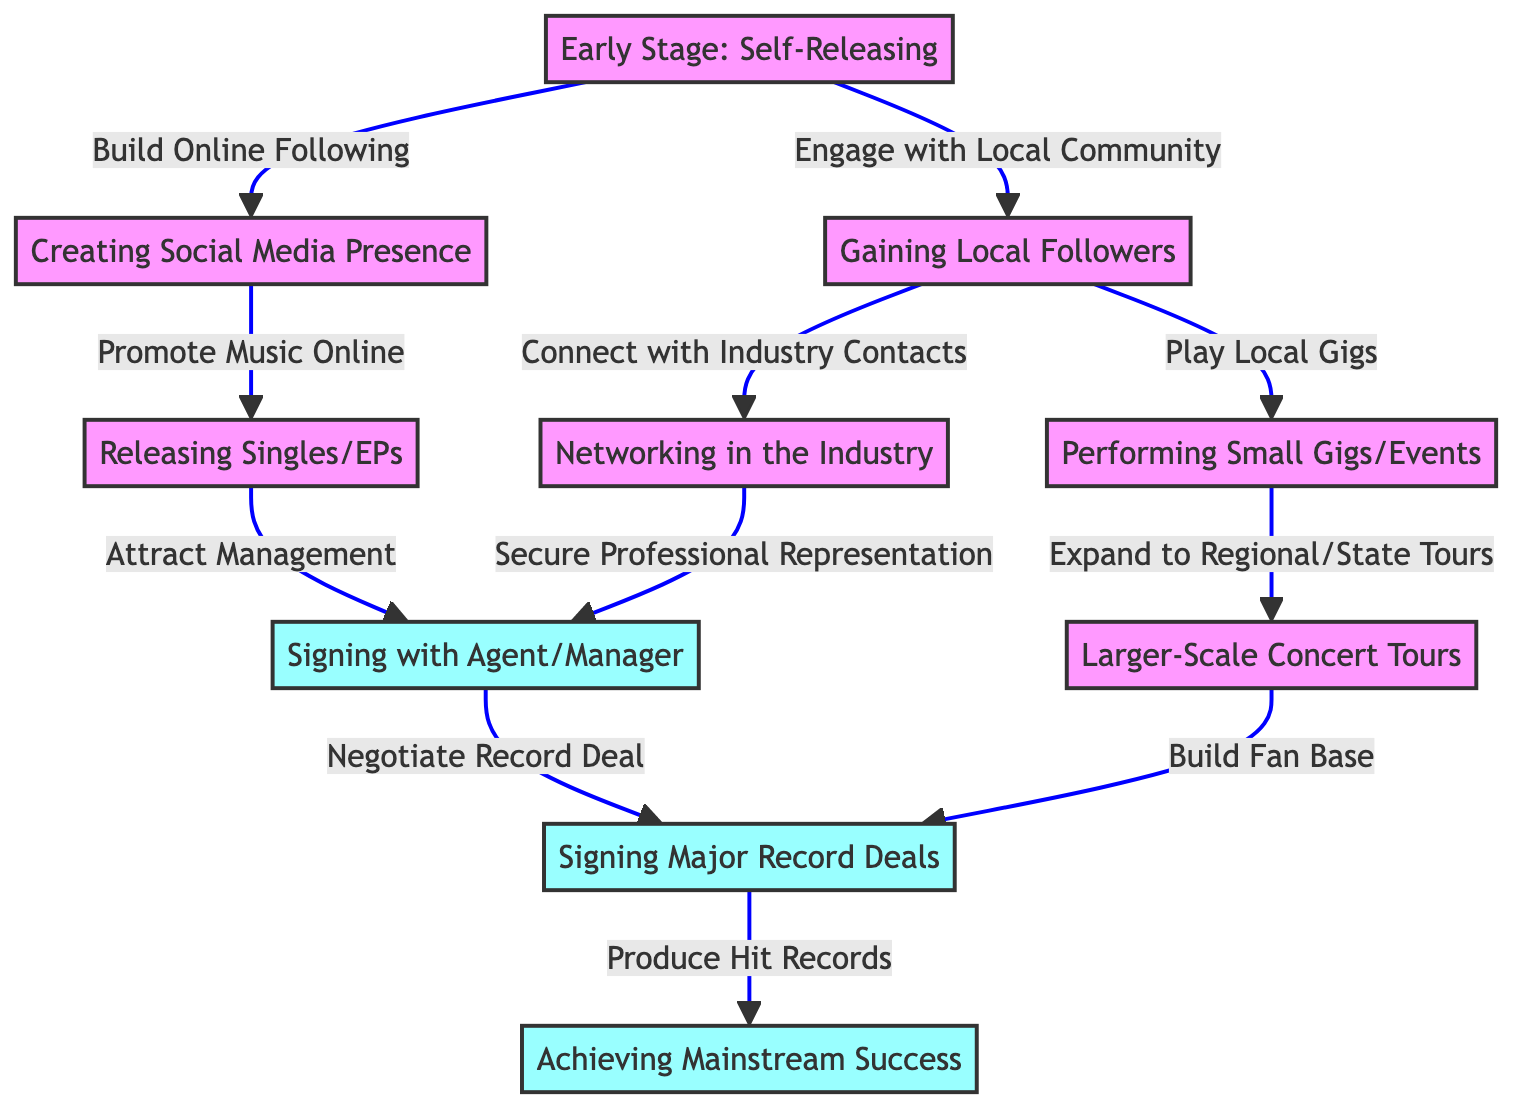What is the first stage of artist development? The diagram clearly shows the first stage labeled as "Early Stage: Self-Releasing." This is the entry point of the artist's career development before they engage in other activities.
Answer: Early Stage: Self-Releasing How many milestones are there in the diagram? The diagram lists four main milestones: signing with agent/manager, signing major record deals, achieving mainstream success, and the implied production of hit records. Each of these is marked distinctly in the flowchart.
Answer: 4 What follows after gaining local followers? According to the flow, after gaining local followers, the artist connects with industry contacts through networking and also plays local gigs. The relationships depicted show these two subsequent actions directly following that stage.
Answer: Networking in the Industry and Performing Small Gigs/Events Which stage leads to larger-scale concert tours? The diagram illustrates that performing small gigs/events leads to regional/state tours, which are classified under larger-scale concert tours. The flow indicates this progression clearly.
Answer: Performing Small Gigs/Events What is the relationship between signing with an agent/manager and major record deals? The diagram indicates a direct relationship where signing with an agent/manager leads to negotiating a record deal, highlighting the importance of management representation in advancing to that milestone.
Answer: Signing with Agent/Manager leads to Negotiating Record Deal What milestone is associated with producing hit records? The diagram links the milestone of producing hit records directly after securing major record deals, suggesting that this phase is a result of the previous contract success.
Answer: Producing Hit Records What enables the artist to build a fan base? The transition from larger-scale concert tours to securing major record deals outlines that as artists tour and perform, they gather followers leading to a stronger fan base before achieving more significant success.
Answer: Larger-Scale Concert Tours What activity is recommended after creating a social media presence? The next recommended activity post-creating a social media presence is to promote music online with new releases. This showcases the importance of utilizing online platforms.
Answer: Promoting Music Online What does the diagram suggest as a way to secure professional representation? The connection implies that networking in the industry is crucial for securing a professional representation, indicating a dependency between these two stages.
Answer: Networking in the Industry 